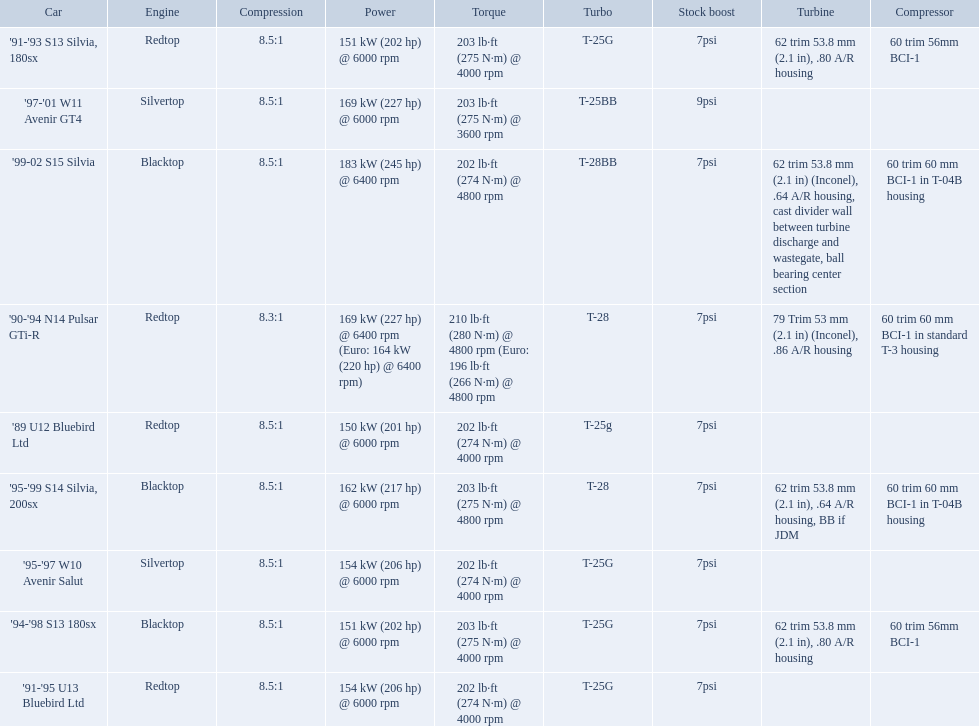What are all of the cars? '89 U12 Bluebird Ltd, '91-'95 U13 Bluebird Ltd, '95-'97 W10 Avenir Salut, '97-'01 W11 Avenir GT4, '90-'94 N14 Pulsar GTi-R, '91-'93 S13 Silvia, 180sx, '94-'98 S13 180sx, '95-'99 S14 Silvia, 200sx, '99-02 S15 Silvia. What is their rated power? 150 kW (201 hp) @ 6000 rpm, 154 kW (206 hp) @ 6000 rpm, 154 kW (206 hp) @ 6000 rpm, 169 kW (227 hp) @ 6000 rpm, 169 kW (227 hp) @ 6400 rpm (Euro: 164 kW (220 hp) @ 6400 rpm), 151 kW (202 hp) @ 6000 rpm, 151 kW (202 hp) @ 6000 rpm, 162 kW (217 hp) @ 6000 rpm, 183 kW (245 hp) @ 6400 rpm. Which car has the most power? '99-02 S15 Silvia. 